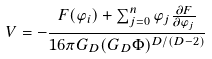Convert formula to latex. <formula><loc_0><loc_0><loc_500><loc_500>V = - \frac { F ( \varphi _ { i } ) + \sum _ { j = 0 } ^ { n } \varphi _ { j } \frac { \partial F } { \partial \varphi _ { j } } } { 1 6 \pi G _ { D } ( G _ { D } \Phi ) ^ { D / ( D - 2 ) } }</formula> 